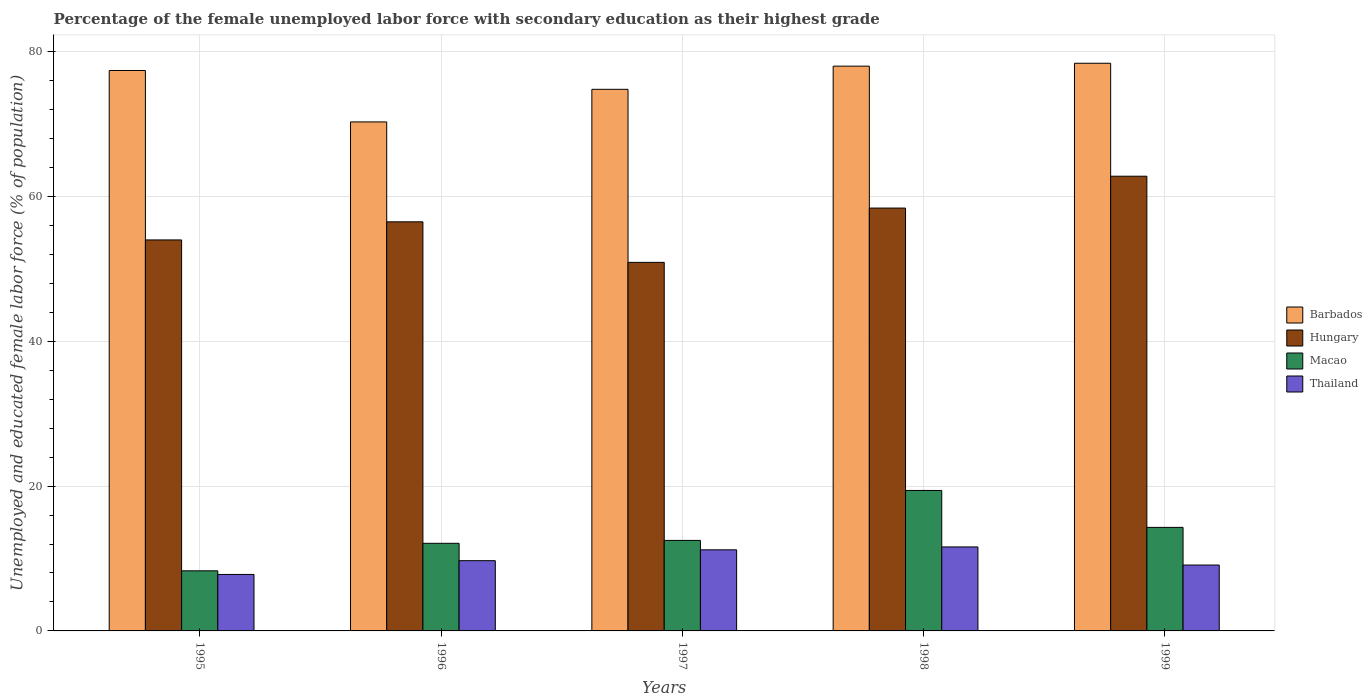How many different coloured bars are there?
Your answer should be very brief. 4. How many groups of bars are there?
Provide a short and direct response. 5. Are the number of bars per tick equal to the number of legend labels?
Offer a very short reply. Yes. Are the number of bars on each tick of the X-axis equal?
Your response must be concise. Yes. How many bars are there on the 5th tick from the left?
Make the answer very short. 4. In how many cases, is the number of bars for a given year not equal to the number of legend labels?
Provide a succinct answer. 0. Across all years, what is the maximum percentage of the unemployed female labor force with secondary education in Barbados?
Ensure brevity in your answer.  78.4. Across all years, what is the minimum percentage of the unemployed female labor force with secondary education in Barbados?
Provide a succinct answer. 70.3. In which year was the percentage of the unemployed female labor force with secondary education in Macao maximum?
Ensure brevity in your answer.  1998. In which year was the percentage of the unemployed female labor force with secondary education in Thailand minimum?
Keep it short and to the point. 1995. What is the total percentage of the unemployed female labor force with secondary education in Thailand in the graph?
Make the answer very short. 49.4. What is the difference between the percentage of the unemployed female labor force with secondary education in Thailand in 1995 and that in 1997?
Offer a terse response. -3.4. What is the difference between the percentage of the unemployed female labor force with secondary education in Thailand in 1997 and the percentage of the unemployed female labor force with secondary education in Hungary in 1996?
Make the answer very short. -45.3. What is the average percentage of the unemployed female labor force with secondary education in Barbados per year?
Your answer should be compact. 75.78. In the year 1999, what is the difference between the percentage of the unemployed female labor force with secondary education in Barbados and percentage of the unemployed female labor force with secondary education in Thailand?
Ensure brevity in your answer.  69.3. In how many years, is the percentage of the unemployed female labor force with secondary education in Macao greater than 52 %?
Ensure brevity in your answer.  0. What is the ratio of the percentage of the unemployed female labor force with secondary education in Macao in 1996 to that in 1997?
Offer a very short reply. 0.97. Is the percentage of the unemployed female labor force with secondary education in Macao in 1996 less than that in 1998?
Make the answer very short. Yes. Is the difference between the percentage of the unemployed female labor force with secondary education in Barbados in 1997 and 1998 greater than the difference between the percentage of the unemployed female labor force with secondary education in Thailand in 1997 and 1998?
Provide a short and direct response. No. What is the difference between the highest and the second highest percentage of the unemployed female labor force with secondary education in Hungary?
Your answer should be very brief. 4.4. What is the difference between the highest and the lowest percentage of the unemployed female labor force with secondary education in Barbados?
Your answer should be very brief. 8.1. In how many years, is the percentage of the unemployed female labor force with secondary education in Thailand greater than the average percentage of the unemployed female labor force with secondary education in Thailand taken over all years?
Ensure brevity in your answer.  2. Is it the case that in every year, the sum of the percentage of the unemployed female labor force with secondary education in Thailand and percentage of the unemployed female labor force with secondary education in Hungary is greater than the sum of percentage of the unemployed female labor force with secondary education in Macao and percentage of the unemployed female labor force with secondary education in Barbados?
Give a very brief answer. Yes. What does the 3rd bar from the left in 1997 represents?
Keep it short and to the point. Macao. What does the 2nd bar from the right in 1997 represents?
Offer a terse response. Macao. How many bars are there?
Make the answer very short. 20. How many years are there in the graph?
Keep it short and to the point. 5. Does the graph contain grids?
Make the answer very short. Yes. How many legend labels are there?
Your response must be concise. 4. How are the legend labels stacked?
Offer a very short reply. Vertical. What is the title of the graph?
Your response must be concise. Percentage of the female unemployed labor force with secondary education as their highest grade. What is the label or title of the Y-axis?
Give a very brief answer. Unemployed and educated female labor force (% of population). What is the Unemployed and educated female labor force (% of population) of Barbados in 1995?
Offer a terse response. 77.4. What is the Unemployed and educated female labor force (% of population) of Hungary in 1995?
Keep it short and to the point. 54. What is the Unemployed and educated female labor force (% of population) of Macao in 1995?
Keep it short and to the point. 8.3. What is the Unemployed and educated female labor force (% of population) in Thailand in 1995?
Give a very brief answer. 7.8. What is the Unemployed and educated female labor force (% of population) of Barbados in 1996?
Provide a short and direct response. 70.3. What is the Unemployed and educated female labor force (% of population) of Hungary in 1996?
Your answer should be compact. 56.5. What is the Unemployed and educated female labor force (% of population) in Macao in 1996?
Provide a short and direct response. 12.1. What is the Unemployed and educated female labor force (% of population) in Thailand in 1996?
Give a very brief answer. 9.7. What is the Unemployed and educated female labor force (% of population) in Barbados in 1997?
Keep it short and to the point. 74.8. What is the Unemployed and educated female labor force (% of population) of Hungary in 1997?
Give a very brief answer. 50.9. What is the Unemployed and educated female labor force (% of population) in Thailand in 1997?
Your response must be concise. 11.2. What is the Unemployed and educated female labor force (% of population) of Hungary in 1998?
Your response must be concise. 58.4. What is the Unemployed and educated female labor force (% of population) of Macao in 1998?
Give a very brief answer. 19.4. What is the Unemployed and educated female labor force (% of population) in Thailand in 1998?
Keep it short and to the point. 11.6. What is the Unemployed and educated female labor force (% of population) of Barbados in 1999?
Your answer should be very brief. 78.4. What is the Unemployed and educated female labor force (% of population) in Hungary in 1999?
Provide a succinct answer. 62.8. What is the Unemployed and educated female labor force (% of population) in Macao in 1999?
Make the answer very short. 14.3. What is the Unemployed and educated female labor force (% of population) of Thailand in 1999?
Ensure brevity in your answer.  9.1. Across all years, what is the maximum Unemployed and educated female labor force (% of population) of Barbados?
Keep it short and to the point. 78.4. Across all years, what is the maximum Unemployed and educated female labor force (% of population) in Hungary?
Give a very brief answer. 62.8. Across all years, what is the maximum Unemployed and educated female labor force (% of population) in Macao?
Your response must be concise. 19.4. Across all years, what is the maximum Unemployed and educated female labor force (% of population) in Thailand?
Offer a terse response. 11.6. Across all years, what is the minimum Unemployed and educated female labor force (% of population) of Barbados?
Offer a terse response. 70.3. Across all years, what is the minimum Unemployed and educated female labor force (% of population) in Hungary?
Give a very brief answer. 50.9. Across all years, what is the minimum Unemployed and educated female labor force (% of population) in Macao?
Give a very brief answer. 8.3. Across all years, what is the minimum Unemployed and educated female labor force (% of population) of Thailand?
Offer a terse response. 7.8. What is the total Unemployed and educated female labor force (% of population) in Barbados in the graph?
Keep it short and to the point. 378.9. What is the total Unemployed and educated female labor force (% of population) of Hungary in the graph?
Your answer should be compact. 282.6. What is the total Unemployed and educated female labor force (% of population) of Macao in the graph?
Keep it short and to the point. 66.6. What is the total Unemployed and educated female labor force (% of population) of Thailand in the graph?
Give a very brief answer. 49.4. What is the difference between the Unemployed and educated female labor force (% of population) of Macao in 1995 and that in 1996?
Your answer should be very brief. -3.8. What is the difference between the Unemployed and educated female labor force (% of population) in Barbados in 1995 and that in 1997?
Provide a succinct answer. 2.6. What is the difference between the Unemployed and educated female labor force (% of population) of Hungary in 1995 and that in 1997?
Offer a very short reply. 3.1. What is the difference between the Unemployed and educated female labor force (% of population) in Macao in 1995 and that in 1997?
Your answer should be compact. -4.2. What is the difference between the Unemployed and educated female labor force (% of population) of Thailand in 1995 and that in 1997?
Offer a very short reply. -3.4. What is the difference between the Unemployed and educated female labor force (% of population) of Barbados in 1995 and that in 1998?
Give a very brief answer. -0.6. What is the difference between the Unemployed and educated female labor force (% of population) in Hungary in 1995 and that in 1998?
Give a very brief answer. -4.4. What is the difference between the Unemployed and educated female labor force (% of population) in Macao in 1995 and that in 1998?
Give a very brief answer. -11.1. What is the difference between the Unemployed and educated female labor force (% of population) in Thailand in 1995 and that in 1998?
Offer a terse response. -3.8. What is the difference between the Unemployed and educated female labor force (% of population) of Macao in 1995 and that in 1999?
Your response must be concise. -6. What is the difference between the Unemployed and educated female labor force (% of population) of Thailand in 1995 and that in 1999?
Your response must be concise. -1.3. What is the difference between the Unemployed and educated female labor force (% of population) in Barbados in 1996 and that in 1997?
Your answer should be very brief. -4.5. What is the difference between the Unemployed and educated female labor force (% of population) in Thailand in 1996 and that in 1997?
Make the answer very short. -1.5. What is the difference between the Unemployed and educated female labor force (% of population) of Hungary in 1996 and that in 1998?
Provide a succinct answer. -1.9. What is the difference between the Unemployed and educated female labor force (% of population) in Hungary in 1996 and that in 1999?
Offer a terse response. -6.3. What is the difference between the Unemployed and educated female labor force (% of population) in Thailand in 1996 and that in 1999?
Your answer should be compact. 0.6. What is the difference between the Unemployed and educated female labor force (% of population) of Hungary in 1997 and that in 1998?
Provide a short and direct response. -7.5. What is the difference between the Unemployed and educated female labor force (% of population) of Macao in 1997 and that in 1998?
Provide a short and direct response. -6.9. What is the difference between the Unemployed and educated female labor force (% of population) in Thailand in 1997 and that in 1998?
Your answer should be compact. -0.4. What is the difference between the Unemployed and educated female labor force (% of population) of Hungary in 1997 and that in 1999?
Make the answer very short. -11.9. What is the difference between the Unemployed and educated female labor force (% of population) in Thailand in 1997 and that in 1999?
Provide a succinct answer. 2.1. What is the difference between the Unemployed and educated female labor force (% of population) in Barbados in 1995 and the Unemployed and educated female labor force (% of population) in Hungary in 1996?
Provide a short and direct response. 20.9. What is the difference between the Unemployed and educated female labor force (% of population) of Barbados in 1995 and the Unemployed and educated female labor force (% of population) of Macao in 1996?
Your answer should be compact. 65.3. What is the difference between the Unemployed and educated female labor force (% of population) in Barbados in 1995 and the Unemployed and educated female labor force (% of population) in Thailand in 1996?
Provide a succinct answer. 67.7. What is the difference between the Unemployed and educated female labor force (% of population) of Hungary in 1995 and the Unemployed and educated female labor force (% of population) of Macao in 1996?
Give a very brief answer. 41.9. What is the difference between the Unemployed and educated female labor force (% of population) of Hungary in 1995 and the Unemployed and educated female labor force (% of population) of Thailand in 1996?
Your answer should be very brief. 44.3. What is the difference between the Unemployed and educated female labor force (% of population) in Barbados in 1995 and the Unemployed and educated female labor force (% of population) in Hungary in 1997?
Provide a succinct answer. 26.5. What is the difference between the Unemployed and educated female labor force (% of population) of Barbados in 1995 and the Unemployed and educated female labor force (% of population) of Macao in 1997?
Your answer should be compact. 64.9. What is the difference between the Unemployed and educated female labor force (% of population) of Barbados in 1995 and the Unemployed and educated female labor force (% of population) of Thailand in 1997?
Your answer should be very brief. 66.2. What is the difference between the Unemployed and educated female labor force (% of population) of Hungary in 1995 and the Unemployed and educated female labor force (% of population) of Macao in 1997?
Keep it short and to the point. 41.5. What is the difference between the Unemployed and educated female labor force (% of population) in Hungary in 1995 and the Unemployed and educated female labor force (% of population) in Thailand in 1997?
Make the answer very short. 42.8. What is the difference between the Unemployed and educated female labor force (% of population) in Barbados in 1995 and the Unemployed and educated female labor force (% of population) in Hungary in 1998?
Provide a succinct answer. 19. What is the difference between the Unemployed and educated female labor force (% of population) of Barbados in 1995 and the Unemployed and educated female labor force (% of population) of Macao in 1998?
Your response must be concise. 58. What is the difference between the Unemployed and educated female labor force (% of population) in Barbados in 1995 and the Unemployed and educated female labor force (% of population) in Thailand in 1998?
Keep it short and to the point. 65.8. What is the difference between the Unemployed and educated female labor force (% of population) in Hungary in 1995 and the Unemployed and educated female labor force (% of population) in Macao in 1998?
Your answer should be very brief. 34.6. What is the difference between the Unemployed and educated female labor force (% of population) of Hungary in 1995 and the Unemployed and educated female labor force (% of population) of Thailand in 1998?
Your answer should be compact. 42.4. What is the difference between the Unemployed and educated female labor force (% of population) in Macao in 1995 and the Unemployed and educated female labor force (% of population) in Thailand in 1998?
Your answer should be very brief. -3.3. What is the difference between the Unemployed and educated female labor force (% of population) in Barbados in 1995 and the Unemployed and educated female labor force (% of population) in Macao in 1999?
Make the answer very short. 63.1. What is the difference between the Unemployed and educated female labor force (% of population) in Barbados in 1995 and the Unemployed and educated female labor force (% of population) in Thailand in 1999?
Your response must be concise. 68.3. What is the difference between the Unemployed and educated female labor force (% of population) in Hungary in 1995 and the Unemployed and educated female labor force (% of population) in Macao in 1999?
Provide a short and direct response. 39.7. What is the difference between the Unemployed and educated female labor force (% of population) of Hungary in 1995 and the Unemployed and educated female labor force (% of population) of Thailand in 1999?
Offer a terse response. 44.9. What is the difference between the Unemployed and educated female labor force (% of population) in Macao in 1995 and the Unemployed and educated female labor force (% of population) in Thailand in 1999?
Provide a short and direct response. -0.8. What is the difference between the Unemployed and educated female labor force (% of population) in Barbados in 1996 and the Unemployed and educated female labor force (% of population) in Macao in 1997?
Offer a very short reply. 57.8. What is the difference between the Unemployed and educated female labor force (% of population) in Barbados in 1996 and the Unemployed and educated female labor force (% of population) in Thailand in 1997?
Give a very brief answer. 59.1. What is the difference between the Unemployed and educated female labor force (% of population) in Hungary in 1996 and the Unemployed and educated female labor force (% of population) in Macao in 1997?
Ensure brevity in your answer.  44. What is the difference between the Unemployed and educated female labor force (% of population) in Hungary in 1996 and the Unemployed and educated female labor force (% of population) in Thailand in 1997?
Offer a very short reply. 45.3. What is the difference between the Unemployed and educated female labor force (% of population) in Macao in 1996 and the Unemployed and educated female labor force (% of population) in Thailand in 1997?
Your answer should be compact. 0.9. What is the difference between the Unemployed and educated female labor force (% of population) in Barbados in 1996 and the Unemployed and educated female labor force (% of population) in Hungary in 1998?
Provide a short and direct response. 11.9. What is the difference between the Unemployed and educated female labor force (% of population) of Barbados in 1996 and the Unemployed and educated female labor force (% of population) of Macao in 1998?
Your answer should be compact. 50.9. What is the difference between the Unemployed and educated female labor force (% of population) of Barbados in 1996 and the Unemployed and educated female labor force (% of population) of Thailand in 1998?
Your answer should be compact. 58.7. What is the difference between the Unemployed and educated female labor force (% of population) of Hungary in 1996 and the Unemployed and educated female labor force (% of population) of Macao in 1998?
Make the answer very short. 37.1. What is the difference between the Unemployed and educated female labor force (% of population) in Hungary in 1996 and the Unemployed and educated female labor force (% of population) in Thailand in 1998?
Your answer should be very brief. 44.9. What is the difference between the Unemployed and educated female labor force (% of population) in Barbados in 1996 and the Unemployed and educated female labor force (% of population) in Thailand in 1999?
Provide a succinct answer. 61.2. What is the difference between the Unemployed and educated female labor force (% of population) in Hungary in 1996 and the Unemployed and educated female labor force (% of population) in Macao in 1999?
Your answer should be compact. 42.2. What is the difference between the Unemployed and educated female labor force (% of population) in Hungary in 1996 and the Unemployed and educated female labor force (% of population) in Thailand in 1999?
Keep it short and to the point. 47.4. What is the difference between the Unemployed and educated female labor force (% of population) of Barbados in 1997 and the Unemployed and educated female labor force (% of population) of Macao in 1998?
Make the answer very short. 55.4. What is the difference between the Unemployed and educated female labor force (% of population) of Barbados in 1997 and the Unemployed and educated female labor force (% of population) of Thailand in 1998?
Provide a succinct answer. 63.2. What is the difference between the Unemployed and educated female labor force (% of population) of Hungary in 1997 and the Unemployed and educated female labor force (% of population) of Macao in 1998?
Offer a terse response. 31.5. What is the difference between the Unemployed and educated female labor force (% of population) in Hungary in 1997 and the Unemployed and educated female labor force (% of population) in Thailand in 1998?
Keep it short and to the point. 39.3. What is the difference between the Unemployed and educated female labor force (% of population) of Barbados in 1997 and the Unemployed and educated female labor force (% of population) of Hungary in 1999?
Provide a succinct answer. 12. What is the difference between the Unemployed and educated female labor force (% of population) of Barbados in 1997 and the Unemployed and educated female labor force (% of population) of Macao in 1999?
Provide a succinct answer. 60.5. What is the difference between the Unemployed and educated female labor force (% of population) of Barbados in 1997 and the Unemployed and educated female labor force (% of population) of Thailand in 1999?
Provide a succinct answer. 65.7. What is the difference between the Unemployed and educated female labor force (% of population) in Hungary in 1997 and the Unemployed and educated female labor force (% of population) in Macao in 1999?
Your response must be concise. 36.6. What is the difference between the Unemployed and educated female labor force (% of population) of Hungary in 1997 and the Unemployed and educated female labor force (% of population) of Thailand in 1999?
Make the answer very short. 41.8. What is the difference between the Unemployed and educated female labor force (% of population) of Macao in 1997 and the Unemployed and educated female labor force (% of population) of Thailand in 1999?
Your answer should be very brief. 3.4. What is the difference between the Unemployed and educated female labor force (% of population) in Barbados in 1998 and the Unemployed and educated female labor force (% of population) in Macao in 1999?
Your answer should be compact. 63.7. What is the difference between the Unemployed and educated female labor force (% of population) in Barbados in 1998 and the Unemployed and educated female labor force (% of population) in Thailand in 1999?
Your answer should be compact. 68.9. What is the difference between the Unemployed and educated female labor force (% of population) of Hungary in 1998 and the Unemployed and educated female labor force (% of population) of Macao in 1999?
Your answer should be very brief. 44.1. What is the difference between the Unemployed and educated female labor force (% of population) in Hungary in 1998 and the Unemployed and educated female labor force (% of population) in Thailand in 1999?
Make the answer very short. 49.3. What is the average Unemployed and educated female labor force (% of population) in Barbados per year?
Make the answer very short. 75.78. What is the average Unemployed and educated female labor force (% of population) in Hungary per year?
Give a very brief answer. 56.52. What is the average Unemployed and educated female labor force (% of population) of Macao per year?
Your response must be concise. 13.32. What is the average Unemployed and educated female labor force (% of population) of Thailand per year?
Offer a terse response. 9.88. In the year 1995, what is the difference between the Unemployed and educated female labor force (% of population) of Barbados and Unemployed and educated female labor force (% of population) of Hungary?
Your response must be concise. 23.4. In the year 1995, what is the difference between the Unemployed and educated female labor force (% of population) of Barbados and Unemployed and educated female labor force (% of population) of Macao?
Your answer should be very brief. 69.1. In the year 1995, what is the difference between the Unemployed and educated female labor force (% of population) of Barbados and Unemployed and educated female labor force (% of population) of Thailand?
Your answer should be compact. 69.6. In the year 1995, what is the difference between the Unemployed and educated female labor force (% of population) of Hungary and Unemployed and educated female labor force (% of population) of Macao?
Your answer should be compact. 45.7. In the year 1995, what is the difference between the Unemployed and educated female labor force (% of population) in Hungary and Unemployed and educated female labor force (% of population) in Thailand?
Offer a terse response. 46.2. In the year 1995, what is the difference between the Unemployed and educated female labor force (% of population) in Macao and Unemployed and educated female labor force (% of population) in Thailand?
Provide a succinct answer. 0.5. In the year 1996, what is the difference between the Unemployed and educated female labor force (% of population) in Barbados and Unemployed and educated female labor force (% of population) in Macao?
Offer a very short reply. 58.2. In the year 1996, what is the difference between the Unemployed and educated female labor force (% of population) in Barbados and Unemployed and educated female labor force (% of population) in Thailand?
Your answer should be compact. 60.6. In the year 1996, what is the difference between the Unemployed and educated female labor force (% of population) in Hungary and Unemployed and educated female labor force (% of population) in Macao?
Provide a succinct answer. 44.4. In the year 1996, what is the difference between the Unemployed and educated female labor force (% of population) of Hungary and Unemployed and educated female labor force (% of population) of Thailand?
Give a very brief answer. 46.8. In the year 1996, what is the difference between the Unemployed and educated female labor force (% of population) of Macao and Unemployed and educated female labor force (% of population) of Thailand?
Give a very brief answer. 2.4. In the year 1997, what is the difference between the Unemployed and educated female labor force (% of population) in Barbados and Unemployed and educated female labor force (% of population) in Hungary?
Provide a succinct answer. 23.9. In the year 1997, what is the difference between the Unemployed and educated female labor force (% of population) in Barbados and Unemployed and educated female labor force (% of population) in Macao?
Your answer should be compact. 62.3. In the year 1997, what is the difference between the Unemployed and educated female labor force (% of population) in Barbados and Unemployed and educated female labor force (% of population) in Thailand?
Offer a terse response. 63.6. In the year 1997, what is the difference between the Unemployed and educated female labor force (% of population) in Hungary and Unemployed and educated female labor force (% of population) in Macao?
Your response must be concise. 38.4. In the year 1997, what is the difference between the Unemployed and educated female labor force (% of population) in Hungary and Unemployed and educated female labor force (% of population) in Thailand?
Offer a terse response. 39.7. In the year 1998, what is the difference between the Unemployed and educated female labor force (% of population) in Barbados and Unemployed and educated female labor force (% of population) in Hungary?
Your answer should be very brief. 19.6. In the year 1998, what is the difference between the Unemployed and educated female labor force (% of population) of Barbados and Unemployed and educated female labor force (% of population) of Macao?
Provide a short and direct response. 58.6. In the year 1998, what is the difference between the Unemployed and educated female labor force (% of population) in Barbados and Unemployed and educated female labor force (% of population) in Thailand?
Offer a terse response. 66.4. In the year 1998, what is the difference between the Unemployed and educated female labor force (% of population) of Hungary and Unemployed and educated female labor force (% of population) of Macao?
Keep it short and to the point. 39. In the year 1998, what is the difference between the Unemployed and educated female labor force (% of population) in Hungary and Unemployed and educated female labor force (% of population) in Thailand?
Provide a short and direct response. 46.8. In the year 1998, what is the difference between the Unemployed and educated female labor force (% of population) in Macao and Unemployed and educated female labor force (% of population) in Thailand?
Your response must be concise. 7.8. In the year 1999, what is the difference between the Unemployed and educated female labor force (% of population) of Barbados and Unemployed and educated female labor force (% of population) of Macao?
Your response must be concise. 64.1. In the year 1999, what is the difference between the Unemployed and educated female labor force (% of population) in Barbados and Unemployed and educated female labor force (% of population) in Thailand?
Offer a very short reply. 69.3. In the year 1999, what is the difference between the Unemployed and educated female labor force (% of population) in Hungary and Unemployed and educated female labor force (% of population) in Macao?
Make the answer very short. 48.5. In the year 1999, what is the difference between the Unemployed and educated female labor force (% of population) of Hungary and Unemployed and educated female labor force (% of population) of Thailand?
Give a very brief answer. 53.7. In the year 1999, what is the difference between the Unemployed and educated female labor force (% of population) in Macao and Unemployed and educated female labor force (% of population) in Thailand?
Offer a very short reply. 5.2. What is the ratio of the Unemployed and educated female labor force (% of population) of Barbados in 1995 to that in 1996?
Offer a very short reply. 1.1. What is the ratio of the Unemployed and educated female labor force (% of population) in Hungary in 1995 to that in 1996?
Your answer should be very brief. 0.96. What is the ratio of the Unemployed and educated female labor force (% of population) in Macao in 1995 to that in 1996?
Your response must be concise. 0.69. What is the ratio of the Unemployed and educated female labor force (% of population) of Thailand in 1995 to that in 1996?
Give a very brief answer. 0.8. What is the ratio of the Unemployed and educated female labor force (% of population) in Barbados in 1995 to that in 1997?
Your answer should be very brief. 1.03. What is the ratio of the Unemployed and educated female labor force (% of population) in Hungary in 1995 to that in 1997?
Your response must be concise. 1.06. What is the ratio of the Unemployed and educated female labor force (% of population) of Macao in 1995 to that in 1997?
Your answer should be compact. 0.66. What is the ratio of the Unemployed and educated female labor force (% of population) in Thailand in 1995 to that in 1997?
Your response must be concise. 0.7. What is the ratio of the Unemployed and educated female labor force (% of population) in Hungary in 1995 to that in 1998?
Make the answer very short. 0.92. What is the ratio of the Unemployed and educated female labor force (% of population) in Macao in 1995 to that in 1998?
Your answer should be compact. 0.43. What is the ratio of the Unemployed and educated female labor force (% of population) in Thailand in 1995 to that in 1998?
Your answer should be compact. 0.67. What is the ratio of the Unemployed and educated female labor force (% of population) in Barbados in 1995 to that in 1999?
Offer a terse response. 0.99. What is the ratio of the Unemployed and educated female labor force (% of population) in Hungary in 1995 to that in 1999?
Provide a short and direct response. 0.86. What is the ratio of the Unemployed and educated female labor force (% of population) of Macao in 1995 to that in 1999?
Give a very brief answer. 0.58. What is the ratio of the Unemployed and educated female labor force (% of population) in Barbados in 1996 to that in 1997?
Your answer should be very brief. 0.94. What is the ratio of the Unemployed and educated female labor force (% of population) of Hungary in 1996 to that in 1997?
Your answer should be compact. 1.11. What is the ratio of the Unemployed and educated female labor force (% of population) in Macao in 1996 to that in 1997?
Provide a short and direct response. 0.97. What is the ratio of the Unemployed and educated female labor force (% of population) of Thailand in 1996 to that in 1997?
Your response must be concise. 0.87. What is the ratio of the Unemployed and educated female labor force (% of population) of Barbados in 1996 to that in 1998?
Provide a succinct answer. 0.9. What is the ratio of the Unemployed and educated female labor force (% of population) in Hungary in 1996 to that in 1998?
Ensure brevity in your answer.  0.97. What is the ratio of the Unemployed and educated female labor force (% of population) in Macao in 1996 to that in 1998?
Provide a short and direct response. 0.62. What is the ratio of the Unemployed and educated female labor force (% of population) in Thailand in 1996 to that in 1998?
Provide a succinct answer. 0.84. What is the ratio of the Unemployed and educated female labor force (% of population) of Barbados in 1996 to that in 1999?
Provide a succinct answer. 0.9. What is the ratio of the Unemployed and educated female labor force (% of population) in Hungary in 1996 to that in 1999?
Provide a short and direct response. 0.9. What is the ratio of the Unemployed and educated female labor force (% of population) of Macao in 1996 to that in 1999?
Your answer should be compact. 0.85. What is the ratio of the Unemployed and educated female labor force (% of population) in Thailand in 1996 to that in 1999?
Your response must be concise. 1.07. What is the ratio of the Unemployed and educated female labor force (% of population) of Barbados in 1997 to that in 1998?
Your response must be concise. 0.96. What is the ratio of the Unemployed and educated female labor force (% of population) of Hungary in 1997 to that in 1998?
Your response must be concise. 0.87. What is the ratio of the Unemployed and educated female labor force (% of population) in Macao in 1997 to that in 1998?
Your answer should be compact. 0.64. What is the ratio of the Unemployed and educated female labor force (% of population) of Thailand in 1997 to that in 1998?
Your answer should be compact. 0.97. What is the ratio of the Unemployed and educated female labor force (% of population) in Barbados in 1997 to that in 1999?
Provide a short and direct response. 0.95. What is the ratio of the Unemployed and educated female labor force (% of population) of Hungary in 1997 to that in 1999?
Offer a very short reply. 0.81. What is the ratio of the Unemployed and educated female labor force (% of population) of Macao in 1997 to that in 1999?
Provide a short and direct response. 0.87. What is the ratio of the Unemployed and educated female labor force (% of population) of Thailand in 1997 to that in 1999?
Your answer should be very brief. 1.23. What is the ratio of the Unemployed and educated female labor force (% of population) of Hungary in 1998 to that in 1999?
Offer a terse response. 0.93. What is the ratio of the Unemployed and educated female labor force (% of population) in Macao in 1998 to that in 1999?
Keep it short and to the point. 1.36. What is the ratio of the Unemployed and educated female labor force (% of population) in Thailand in 1998 to that in 1999?
Your answer should be very brief. 1.27. What is the difference between the highest and the second highest Unemployed and educated female labor force (% of population) of Barbados?
Give a very brief answer. 0.4. What is the difference between the highest and the second highest Unemployed and educated female labor force (% of population) of Macao?
Provide a short and direct response. 5.1. 